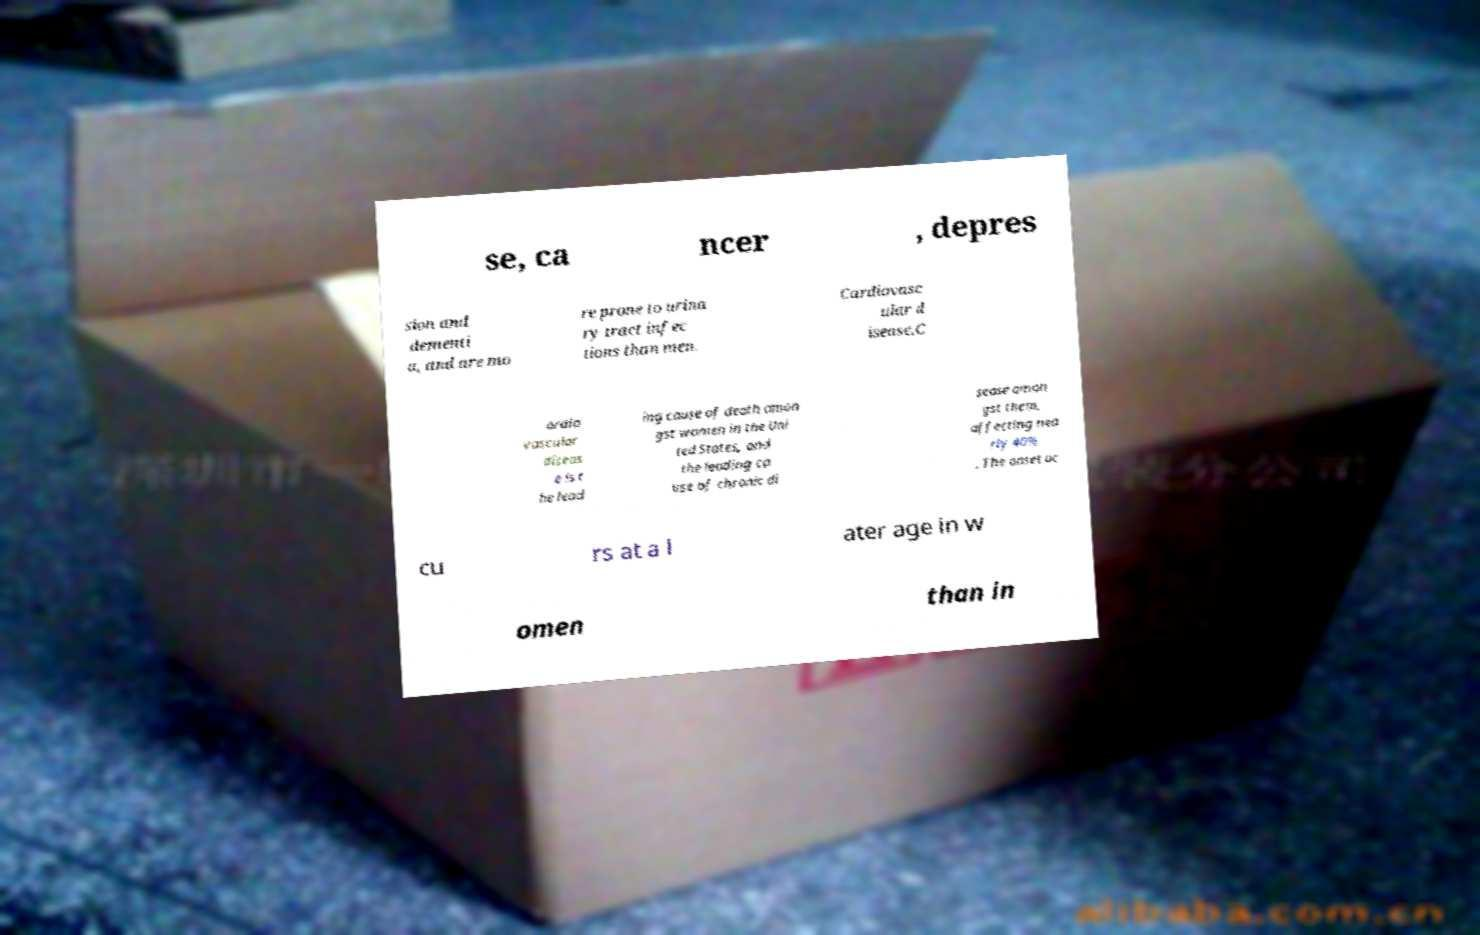There's text embedded in this image that I need extracted. Can you transcribe it verbatim? se, ca ncer , depres sion and dementi a, and are mo re prone to urina ry tract infec tions than men. Cardiovasc ular d isease.C ardio vascular diseas e is t he lead ing cause of death amon gst women in the Uni ted States, and the leading ca use of chronic di sease amon gst them, affecting nea rly 40% . The onset oc cu rs at a l ater age in w omen than in 